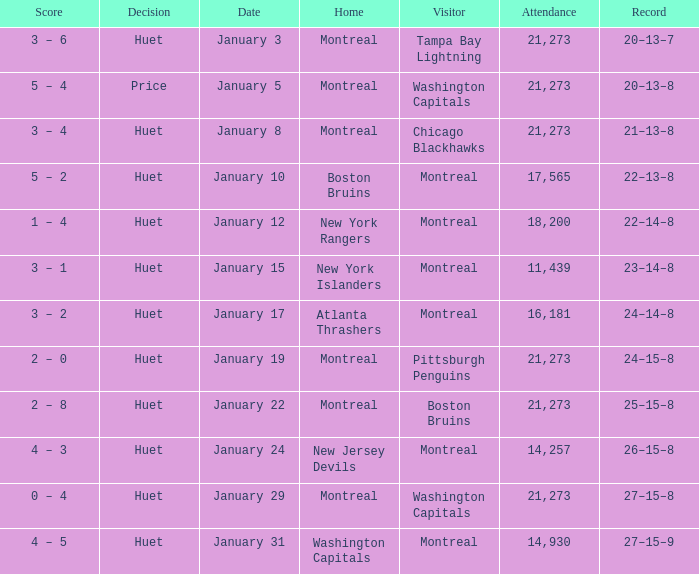What was the score of the game when the Boston Bruins were the visiting team? 2 – 8. 